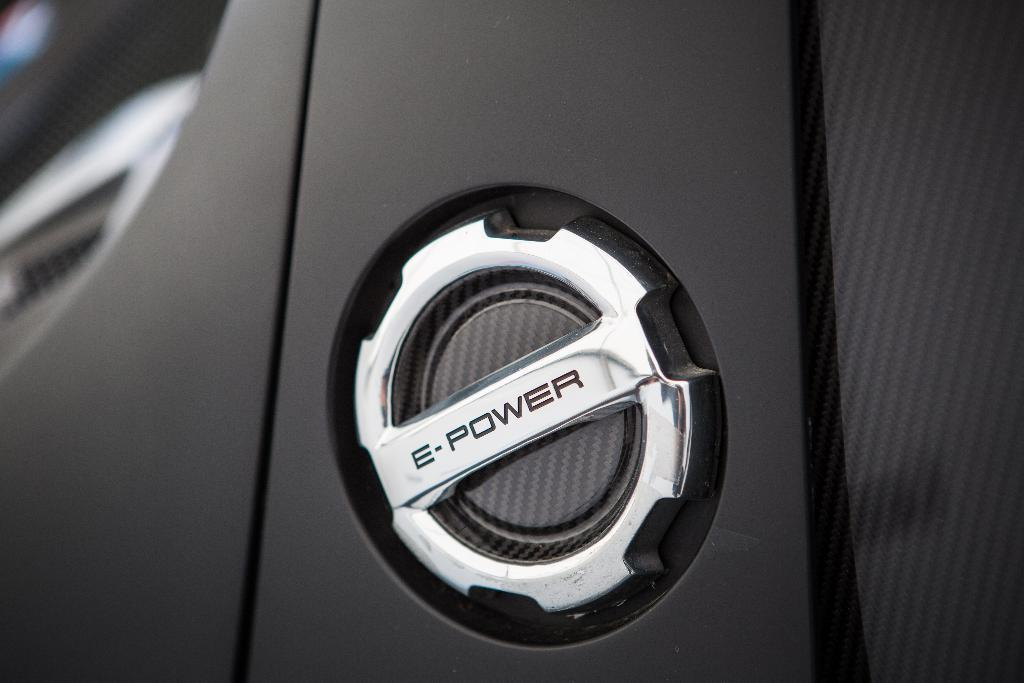What can be seen in the image? There is an object in the image. Can you describe the object in the image? The object has text on it. How many brothers are depicted on the object in the image? There are no brothers depicted on the object in the image. 